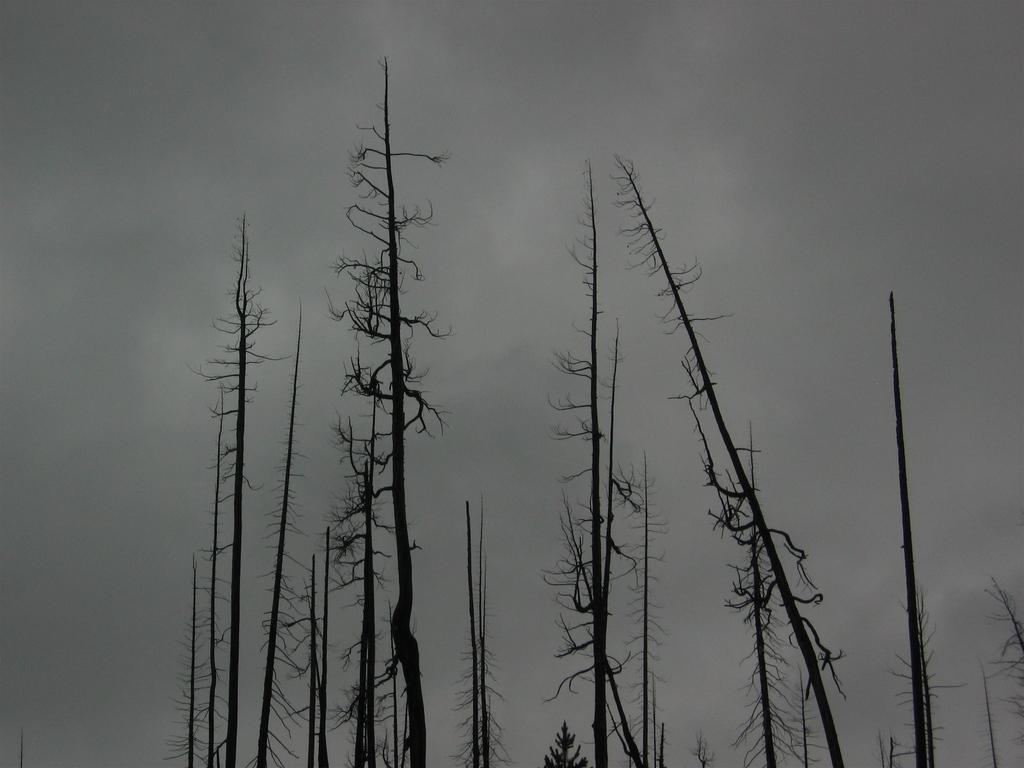What type of vegetation is present in the image? There are dry trees in the image. What part of the natural environment is visible in the image? The sky is visible in the background of the image. How many oranges can be seen hanging from the trees in the image? There are no oranges present in the image; it features dry trees. Can you tell me how many ants are crawling on the eye in the image? There is no eye or ants present in the image. 